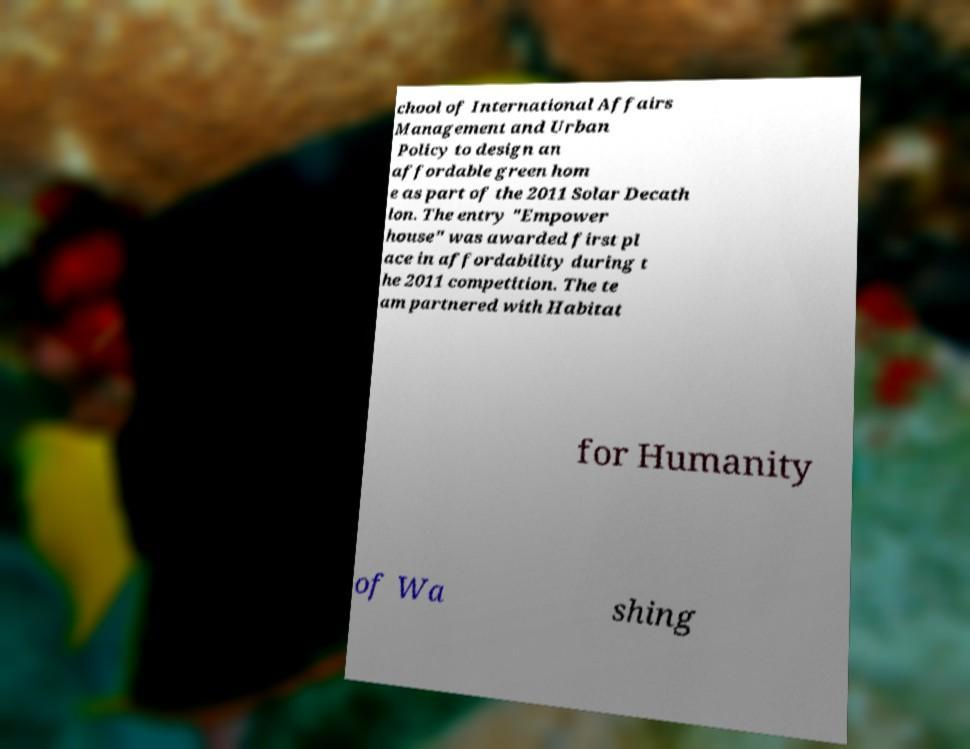Can you read and provide the text displayed in the image?This photo seems to have some interesting text. Can you extract and type it out for me? chool of International Affairs Management and Urban Policy to design an affordable green hom e as part of the 2011 Solar Decath lon. The entry "Empower house" was awarded first pl ace in affordability during t he 2011 competition. The te am partnered with Habitat for Humanity of Wa shing 